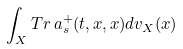Convert formula to latex. <formula><loc_0><loc_0><loc_500><loc_500>\int _ { X } T r \, a ^ { + } _ { s } ( t , x , x ) d v _ { X } ( x )</formula> 